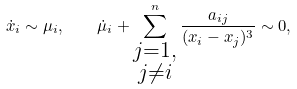<formula> <loc_0><loc_0><loc_500><loc_500>\dot { x } _ { i } \sim \mu _ { i } , \quad \dot { \mu } _ { i } + \sum ^ { n } _ { \substack { j = 1 , \\ j \not = i } } \frac { a _ { i j } } { ( x _ { i } - x _ { j } ) ^ { 3 } } \sim 0 ,</formula> 